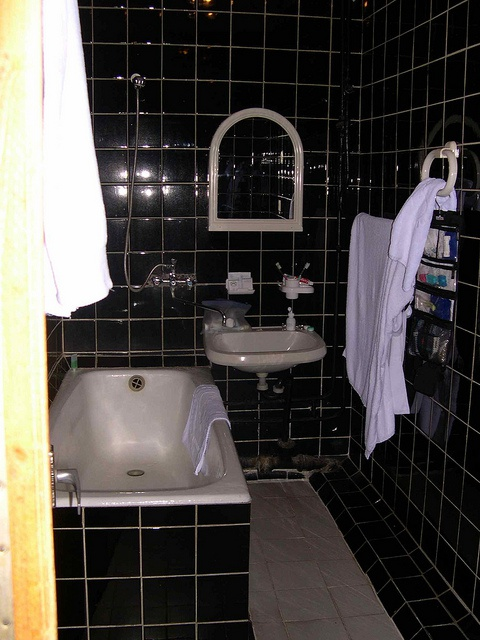Describe the objects in this image and their specific colors. I can see sink in khaki, gray, and black tones, cup in khaki and gray tones, bottle in khaki, darkgray, gray, and navy tones, bottle in khaki, gray, and black tones, and bottle in khaki, gray, darkgreen, and black tones in this image. 